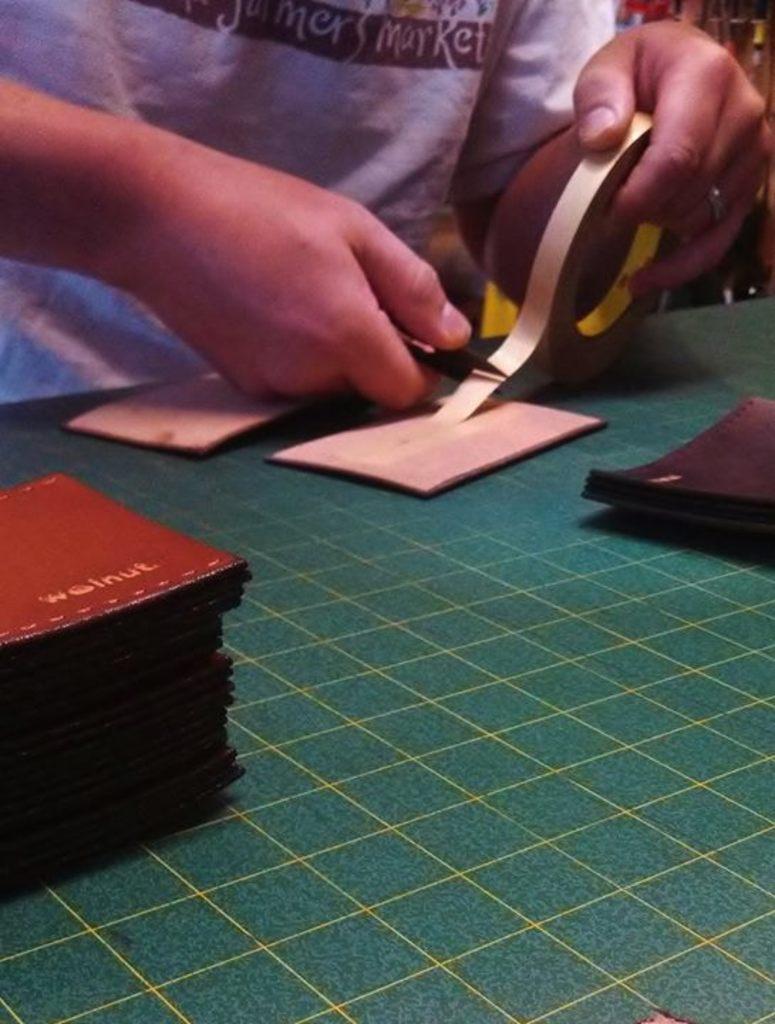Can you describe this image briefly? In this image in the center there are objects which are pink and red in colour on the table. In the background there is a person holding scissor and an object which is pink in colour. 